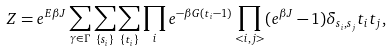<formula> <loc_0><loc_0><loc_500><loc_500>Z = e ^ { E \beta J } \sum _ { \gamma \in \Gamma } \sum _ { \{ s _ { i } \} } \sum _ { \{ t _ { i } \} } \prod _ { i } e ^ { - \beta G ( t _ { i } - 1 ) } \prod _ { < i , j > } ( e ^ { \beta J } - 1 ) \delta _ { s _ { i } , s _ { j } } t _ { i } t _ { j } ,</formula> 